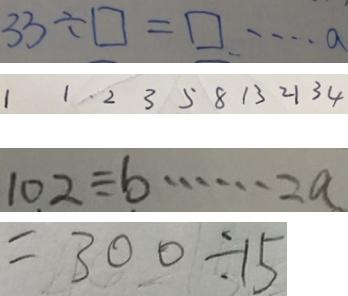<formula> <loc_0><loc_0><loc_500><loc_500>3 3 \div \square = \square \cdots a 
 1 1 2 3 5 8 1 3 2 1 3 4 
 1 0 2 \div b \cdots 2 a 
 = 3 0 0 \div 1 5</formula> 